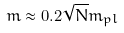Convert formula to latex. <formula><loc_0><loc_0><loc_500><loc_500>m \approx 0 . 2 \sqrt { N } m _ { p l }</formula> 